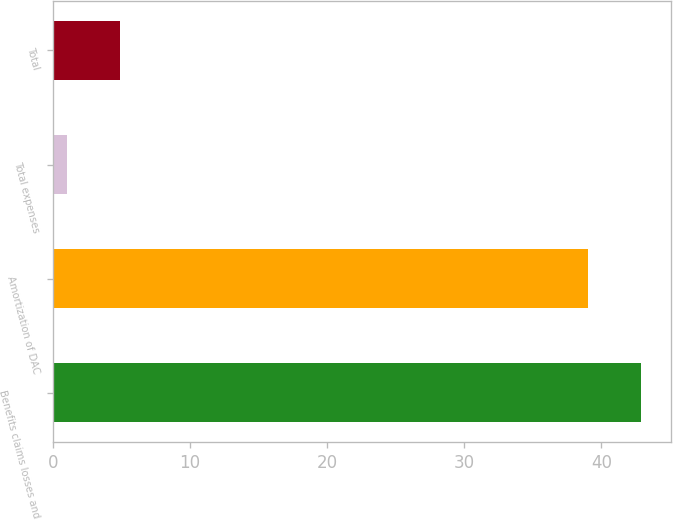Convert chart. <chart><loc_0><loc_0><loc_500><loc_500><bar_chart><fcel>Benefits claims losses and<fcel>Amortization of DAC<fcel>Total expenses<fcel>Total<nl><fcel>42.9<fcel>39<fcel>1<fcel>4.9<nl></chart> 